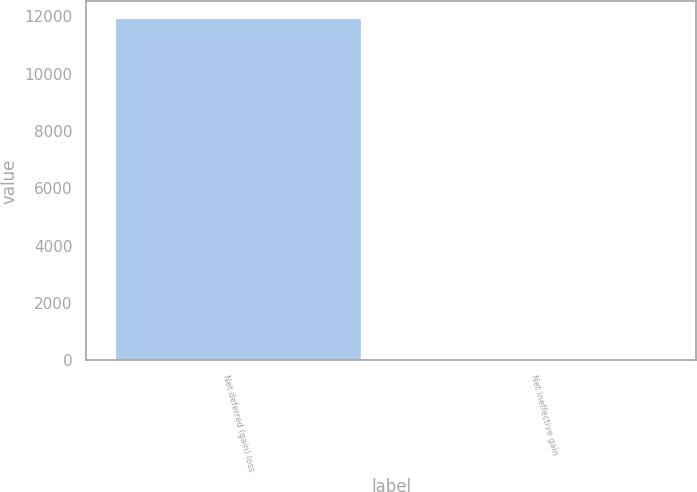<chart> <loc_0><loc_0><loc_500><loc_500><bar_chart><fcel>Net deferred (gain) loss<fcel>Net ineffective gain<nl><fcel>11922<fcel>15<nl></chart> 